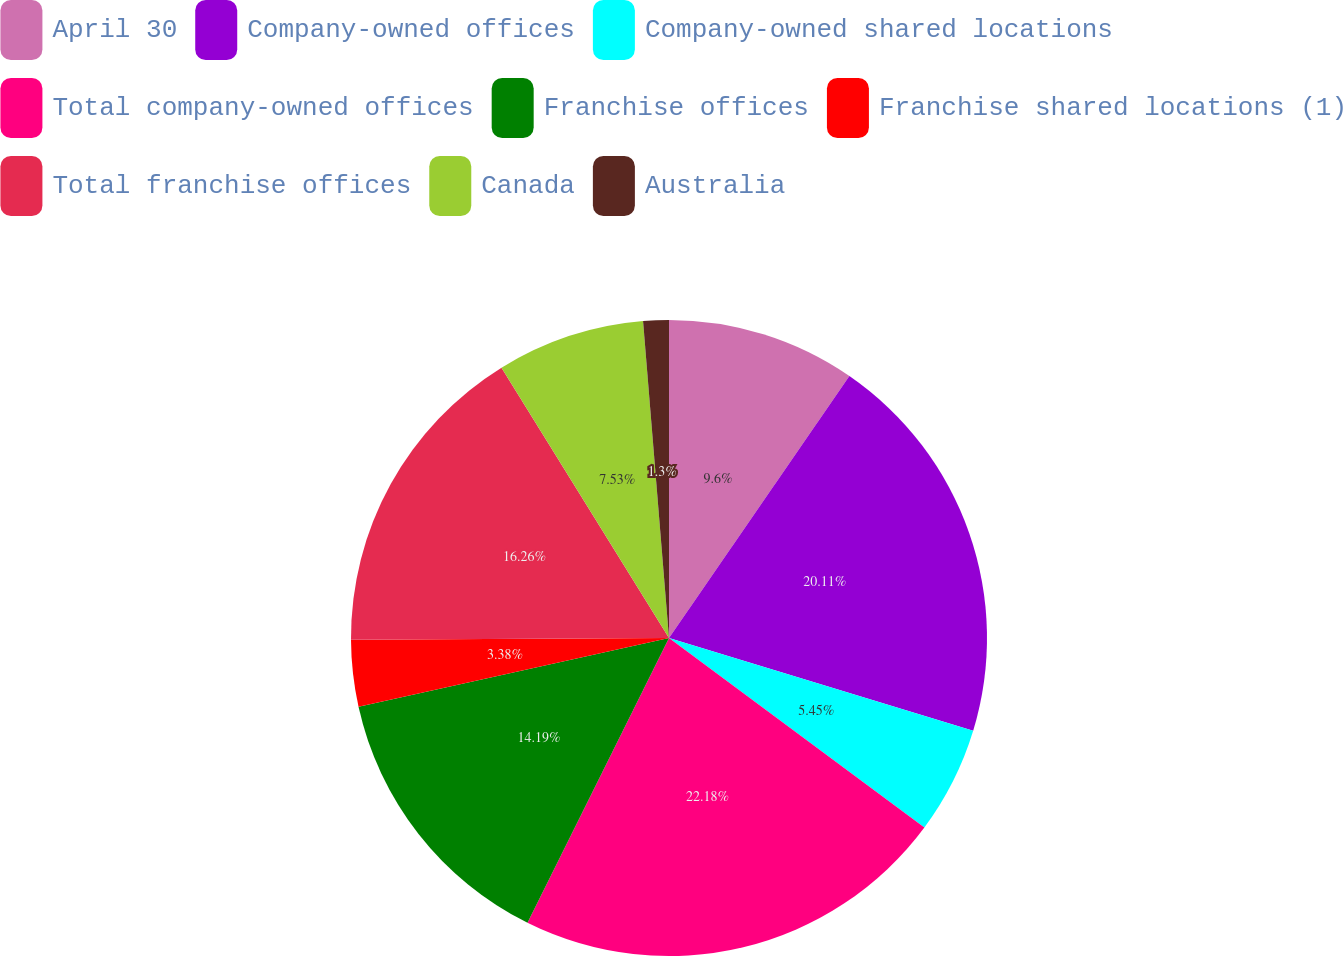Convert chart to OTSL. <chart><loc_0><loc_0><loc_500><loc_500><pie_chart><fcel>April 30<fcel>Company-owned offices<fcel>Company-owned shared locations<fcel>Total company-owned offices<fcel>Franchise offices<fcel>Franchise shared locations (1)<fcel>Total franchise offices<fcel>Canada<fcel>Australia<nl><fcel>9.6%<fcel>20.11%<fcel>5.45%<fcel>22.18%<fcel>14.19%<fcel>3.38%<fcel>16.26%<fcel>7.53%<fcel>1.3%<nl></chart> 